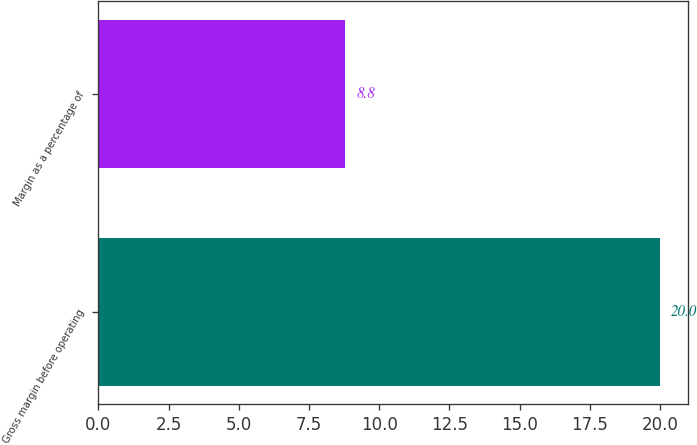<chart> <loc_0><loc_0><loc_500><loc_500><bar_chart><fcel>Gross margin before operating<fcel>Margin as a percentage of<nl><fcel>20<fcel>8.8<nl></chart> 